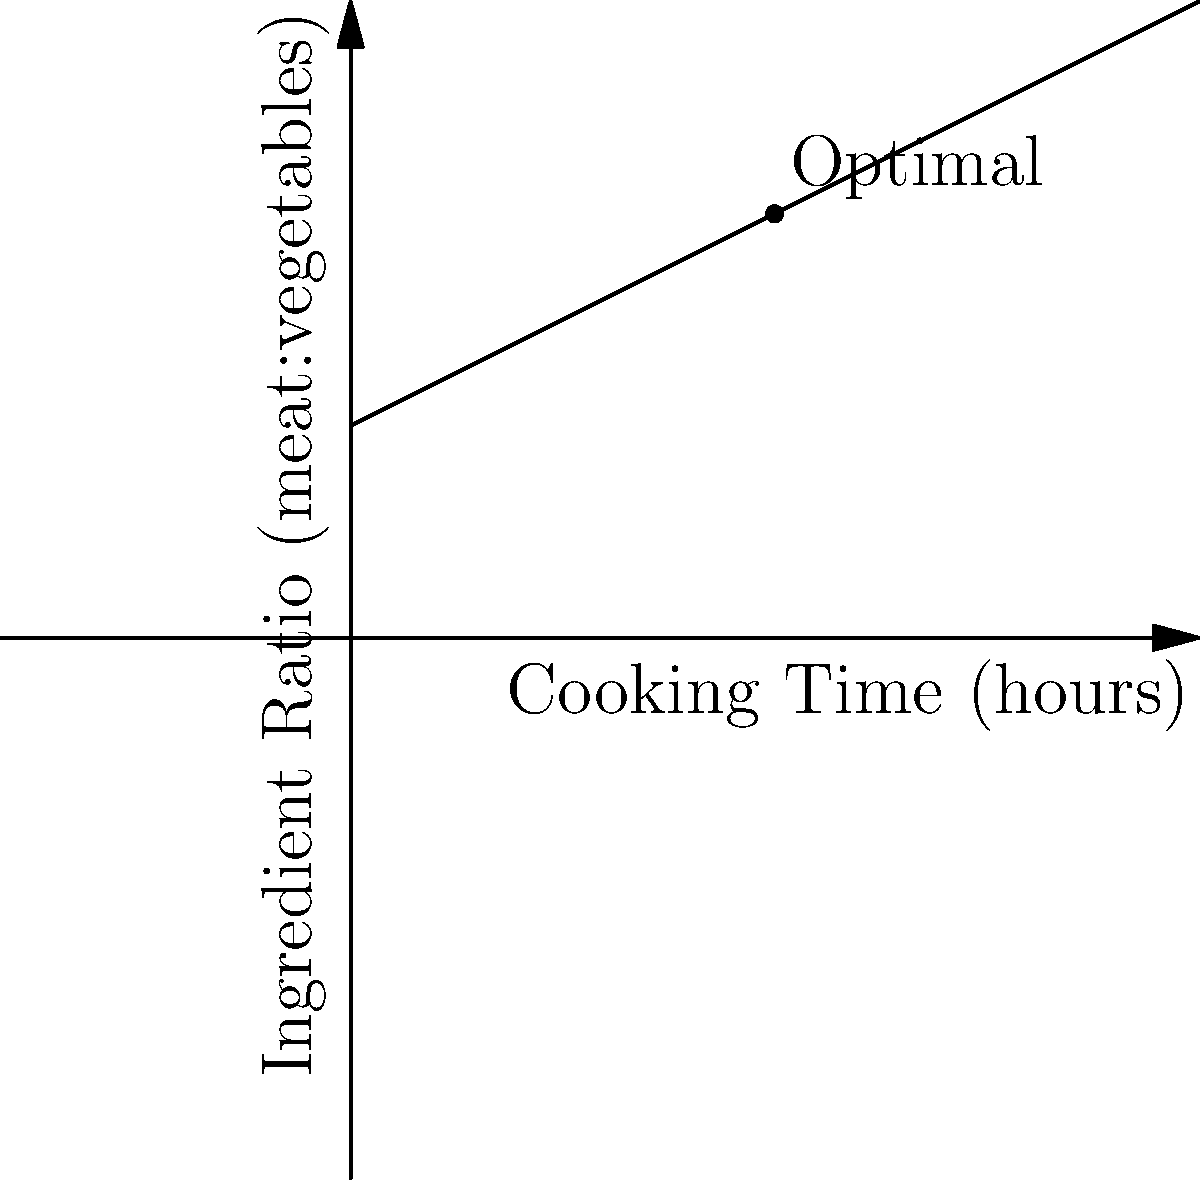Based on the graph showing the relationship between cooking time and ingredient ratio for Irish stew, what is the optimal cooking time when the meat to vegetables ratio is 2:1? To determine the optimal cooking time for Irish stew when the meat to vegetables ratio is 2:1, we need to follow these steps:

1. Understand the graph:
   - The x-axis represents cooking time in hours.
   - The y-axis represents the ingredient ratio (meat:vegetables).
   - The line on the graph shows the optimal relationship between cooking time and ingredient ratio.

2. Locate the point on the y-axis:
   - We're looking for a meat to vegetables ratio of 2:1, which corresponds to y = 2 on the graph.

3. Find the corresponding x-value:
   - Trace a horizontal line from y = 2 until it intersects with the diagonal line on the graph.
   - From this intersection point, draw a vertical line down to the x-axis.

4. Read the x-value:
   - The point where the vertical line meets the x-axis gives us the optimal cooking time.
   - In this case, the intersection occurs at x = 2.

5. Interpret the result:
   - The optimal cooking time for Irish stew with a meat to vegetables ratio of 2:1 is 2 hours.

This relationship allows for adjusting cooking times based on ingredient proportions, ensuring the perfect balance of flavors and textures in traditional Irish stew.
Answer: 2 hours 